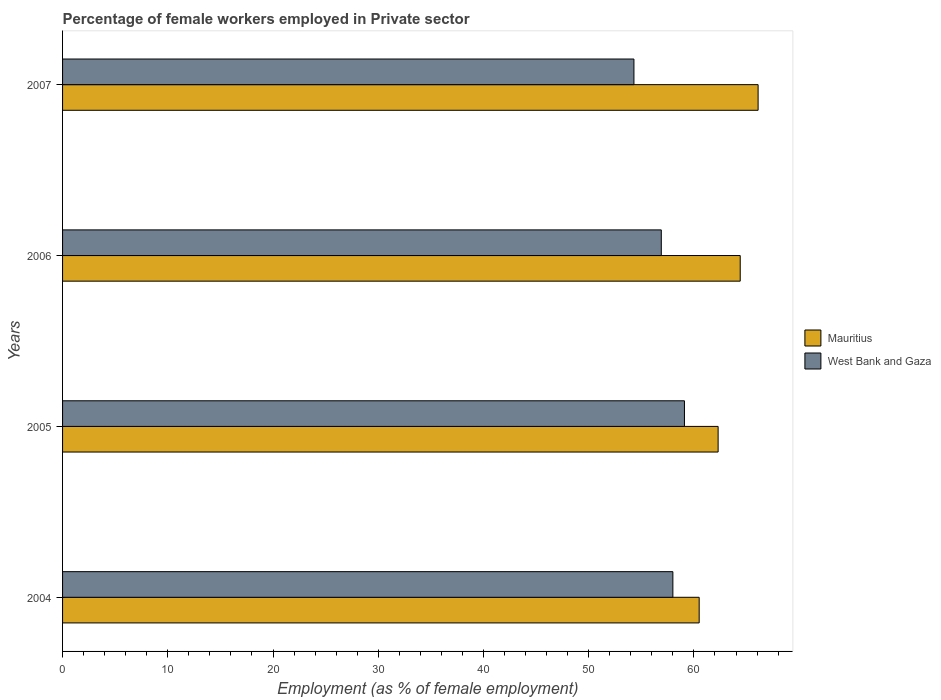How many groups of bars are there?
Your answer should be very brief. 4. Are the number of bars on each tick of the Y-axis equal?
Offer a terse response. Yes. How many bars are there on the 1st tick from the top?
Give a very brief answer. 2. How many bars are there on the 1st tick from the bottom?
Keep it short and to the point. 2. In how many cases, is the number of bars for a given year not equal to the number of legend labels?
Provide a short and direct response. 0. What is the percentage of females employed in Private sector in Mauritius in 2006?
Your response must be concise. 64.4. Across all years, what is the maximum percentage of females employed in Private sector in Mauritius?
Give a very brief answer. 66.1. Across all years, what is the minimum percentage of females employed in Private sector in Mauritius?
Offer a terse response. 60.5. In which year was the percentage of females employed in Private sector in Mauritius maximum?
Ensure brevity in your answer.  2007. What is the total percentage of females employed in Private sector in Mauritius in the graph?
Give a very brief answer. 253.3. What is the difference between the percentage of females employed in Private sector in West Bank and Gaza in 2004 and that in 2007?
Provide a short and direct response. 3.7. What is the difference between the percentage of females employed in Private sector in West Bank and Gaza in 2006 and the percentage of females employed in Private sector in Mauritius in 2007?
Ensure brevity in your answer.  -9.2. What is the average percentage of females employed in Private sector in Mauritius per year?
Make the answer very short. 63.32. In the year 2005, what is the difference between the percentage of females employed in Private sector in West Bank and Gaza and percentage of females employed in Private sector in Mauritius?
Give a very brief answer. -3.2. What is the ratio of the percentage of females employed in Private sector in Mauritius in 2005 to that in 2006?
Make the answer very short. 0.97. Is the difference between the percentage of females employed in Private sector in West Bank and Gaza in 2005 and 2006 greater than the difference between the percentage of females employed in Private sector in Mauritius in 2005 and 2006?
Provide a succinct answer. Yes. What is the difference between the highest and the second highest percentage of females employed in Private sector in West Bank and Gaza?
Keep it short and to the point. 1.1. What is the difference between the highest and the lowest percentage of females employed in Private sector in West Bank and Gaza?
Keep it short and to the point. 4.8. In how many years, is the percentage of females employed in Private sector in Mauritius greater than the average percentage of females employed in Private sector in Mauritius taken over all years?
Your answer should be very brief. 2. Is the sum of the percentage of females employed in Private sector in West Bank and Gaza in 2004 and 2007 greater than the maximum percentage of females employed in Private sector in Mauritius across all years?
Offer a very short reply. Yes. What does the 1st bar from the top in 2005 represents?
Make the answer very short. West Bank and Gaza. What does the 1st bar from the bottom in 2007 represents?
Your answer should be compact. Mauritius. Are all the bars in the graph horizontal?
Provide a short and direct response. Yes. How many years are there in the graph?
Ensure brevity in your answer.  4. What is the difference between two consecutive major ticks on the X-axis?
Keep it short and to the point. 10. Are the values on the major ticks of X-axis written in scientific E-notation?
Provide a short and direct response. No. Does the graph contain grids?
Give a very brief answer. No. How many legend labels are there?
Offer a very short reply. 2. How are the legend labels stacked?
Give a very brief answer. Vertical. What is the title of the graph?
Your answer should be very brief. Percentage of female workers employed in Private sector. What is the label or title of the X-axis?
Give a very brief answer. Employment (as % of female employment). What is the Employment (as % of female employment) in Mauritius in 2004?
Your answer should be very brief. 60.5. What is the Employment (as % of female employment) of Mauritius in 2005?
Ensure brevity in your answer.  62.3. What is the Employment (as % of female employment) in West Bank and Gaza in 2005?
Your response must be concise. 59.1. What is the Employment (as % of female employment) of Mauritius in 2006?
Your answer should be very brief. 64.4. What is the Employment (as % of female employment) in West Bank and Gaza in 2006?
Offer a terse response. 56.9. What is the Employment (as % of female employment) of Mauritius in 2007?
Ensure brevity in your answer.  66.1. What is the Employment (as % of female employment) of West Bank and Gaza in 2007?
Offer a terse response. 54.3. Across all years, what is the maximum Employment (as % of female employment) of Mauritius?
Provide a short and direct response. 66.1. Across all years, what is the maximum Employment (as % of female employment) of West Bank and Gaza?
Give a very brief answer. 59.1. Across all years, what is the minimum Employment (as % of female employment) of Mauritius?
Make the answer very short. 60.5. Across all years, what is the minimum Employment (as % of female employment) of West Bank and Gaza?
Give a very brief answer. 54.3. What is the total Employment (as % of female employment) in Mauritius in the graph?
Provide a short and direct response. 253.3. What is the total Employment (as % of female employment) in West Bank and Gaza in the graph?
Keep it short and to the point. 228.3. What is the difference between the Employment (as % of female employment) of Mauritius in 2004 and that in 2005?
Provide a succinct answer. -1.8. What is the difference between the Employment (as % of female employment) of West Bank and Gaza in 2004 and that in 2007?
Your answer should be very brief. 3.7. What is the difference between the Employment (as % of female employment) of West Bank and Gaza in 2005 and that in 2006?
Provide a short and direct response. 2.2. What is the difference between the Employment (as % of female employment) of West Bank and Gaza in 2005 and that in 2007?
Offer a very short reply. 4.8. What is the difference between the Employment (as % of female employment) in Mauritius in 2006 and that in 2007?
Your answer should be compact. -1.7. What is the difference between the Employment (as % of female employment) in West Bank and Gaza in 2006 and that in 2007?
Offer a terse response. 2.6. What is the difference between the Employment (as % of female employment) in Mauritius in 2004 and the Employment (as % of female employment) in West Bank and Gaza in 2006?
Offer a terse response. 3.6. What is the difference between the Employment (as % of female employment) in Mauritius in 2004 and the Employment (as % of female employment) in West Bank and Gaza in 2007?
Offer a terse response. 6.2. What is the difference between the Employment (as % of female employment) of Mauritius in 2005 and the Employment (as % of female employment) of West Bank and Gaza in 2006?
Keep it short and to the point. 5.4. What is the difference between the Employment (as % of female employment) in Mauritius in 2005 and the Employment (as % of female employment) in West Bank and Gaza in 2007?
Give a very brief answer. 8. What is the difference between the Employment (as % of female employment) of Mauritius in 2006 and the Employment (as % of female employment) of West Bank and Gaza in 2007?
Offer a terse response. 10.1. What is the average Employment (as % of female employment) of Mauritius per year?
Make the answer very short. 63.33. What is the average Employment (as % of female employment) in West Bank and Gaza per year?
Your answer should be compact. 57.08. In the year 2004, what is the difference between the Employment (as % of female employment) in Mauritius and Employment (as % of female employment) in West Bank and Gaza?
Offer a very short reply. 2.5. What is the ratio of the Employment (as % of female employment) in Mauritius in 2004 to that in 2005?
Give a very brief answer. 0.97. What is the ratio of the Employment (as % of female employment) of West Bank and Gaza in 2004 to that in 2005?
Give a very brief answer. 0.98. What is the ratio of the Employment (as % of female employment) in Mauritius in 2004 to that in 2006?
Offer a terse response. 0.94. What is the ratio of the Employment (as % of female employment) of West Bank and Gaza in 2004 to that in 2006?
Keep it short and to the point. 1.02. What is the ratio of the Employment (as % of female employment) of Mauritius in 2004 to that in 2007?
Provide a succinct answer. 0.92. What is the ratio of the Employment (as % of female employment) of West Bank and Gaza in 2004 to that in 2007?
Your answer should be compact. 1.07. What is the ratio of the Employment (as % of female employment) of Mauritius in 2005 to that in 2006?
Keep it short and to the point. 0.97. What is the ratio of the Employment (as % of female employment) of West Bank and Gaza in 2005 to that in 2006?
Your answer should be compact. 1.04. What is the ratio of the Employment (as % of female employment) in Mauritius in 2005 to that in 2007?
Give a very brief answer. 0.94. What is the ratio of the Employment (as % of female employment) of West Bank and Gaza in 2005 to that in 2007?
Keep it short and to the point. 1.09. What is the ratio of the Employment (as % of female employment) of Mauritius in 2006 to that in 2007?
Give a very brief answer. 0.97. What is the ratio of the Employment (as % of female employment) of West Bank and Gaza in 2006 to that in 2007?
Provide a succinct answer. 1.05. What is the difference between the highest and the second highest Employment (as % of female employment) of West Bank and Gaza?
Offer a terse response. 1.1. 